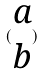Convert formula to latex. <formula><loc_0><loc_0><loc_500><loc_500>( \begin{matrix} a \\ b \end{matrix} )</formula> 